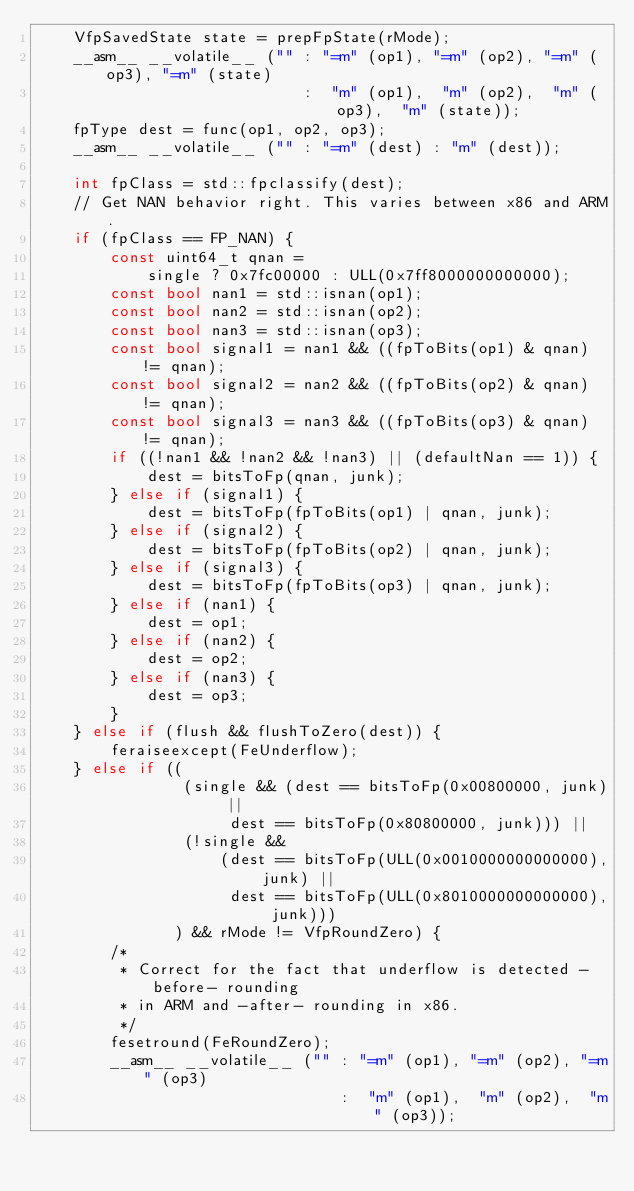Convert code to text. <code><loc_0><loc_0><loc_500><loc_500><_C++_>    VfpSavedState state = prepFpState(rMode);
    __asm__ __volatile__ ("" : "=m" (op1), "=m" (op2), "=m" (op3), "=m" (state)
                             :  "m" (op1),  "m" (op2),  "m" (op3),  "m" (state));
    fpType dest = func(op1, op2, op3);
    __asm__ __volatile__ ("" : "=m" (dest) : "m" (dest));

    int fpClass = std::fpclassify(dest);
    // Get NAN behavior right. This varies between x86 and ARM.
    if (fpClass == FP_NAN) {
        const uint64_t qnan =
            single ? 0x7fc00000 : ULL(0x7ff8000000000000);
        const bool nan1 = std::isnan(op1);
        const bool nan2 = std::isnan(op2);
        const bool nan3 = std::isnan(op3);
        const bool signal1 = nan1 && ((fpToBits(op1) & qnan) != qnan);
        const bool signal2 = nan2 && ((fpToBits(op2) & qnan) != qnan);
        const bool signal3 = nan3 && ((fpToBits(op3) & qnan) != qnan);
        if ((!nan1 && !nan2 && !nan3) || (defaultNan == 1)) {
            dest = bitsToFp(qnan, junk);
        } else if (signal1) {
            dest = bitsToFp(fpToBits(op1) | qnan, junk);
        } else if (signal2) {
            dest = bitsToFp(fpToBits(op2) | qnan, junk);
        } else if (signal3) {
            dest = bitsToFp(fpToBits(op3) | qnan, junk);
        } else if (nan1) {
            dest = op1;
        } else if (nan2) {
            dest = op2;
        } else if (nan3) {
            dest = op3;
        }
    } else if (flush && flushToZero(dest)) {
        feraiseexcept(FeUnderflow);
    } else if ((
                (single && (dest == bitsToFp(0x00800000, junk) ||
                     dest == bitsToFp(0x80800000, junk))) ||
                (!single &&
                    (dest == bitsToFp(ULL(0x0010000000000000), junk) ||
                     dest == bitsToFp(ULL(0x8010000000000000), junk)))
               ) && rMode != VfpRoundZero) {
        /*
         * Correct for the fact that underflow is detected -before- rounding
         * in ARM and -after- rounding in x86.
         */
        fesetround(FeRoundZero);
        __asm__ __volatile__ ("" : "=m" (op1), "=m" (op2), "=m" (op3)
                                 :  "m" (op1),  "m" (op2),  "m" (op3));</code> 